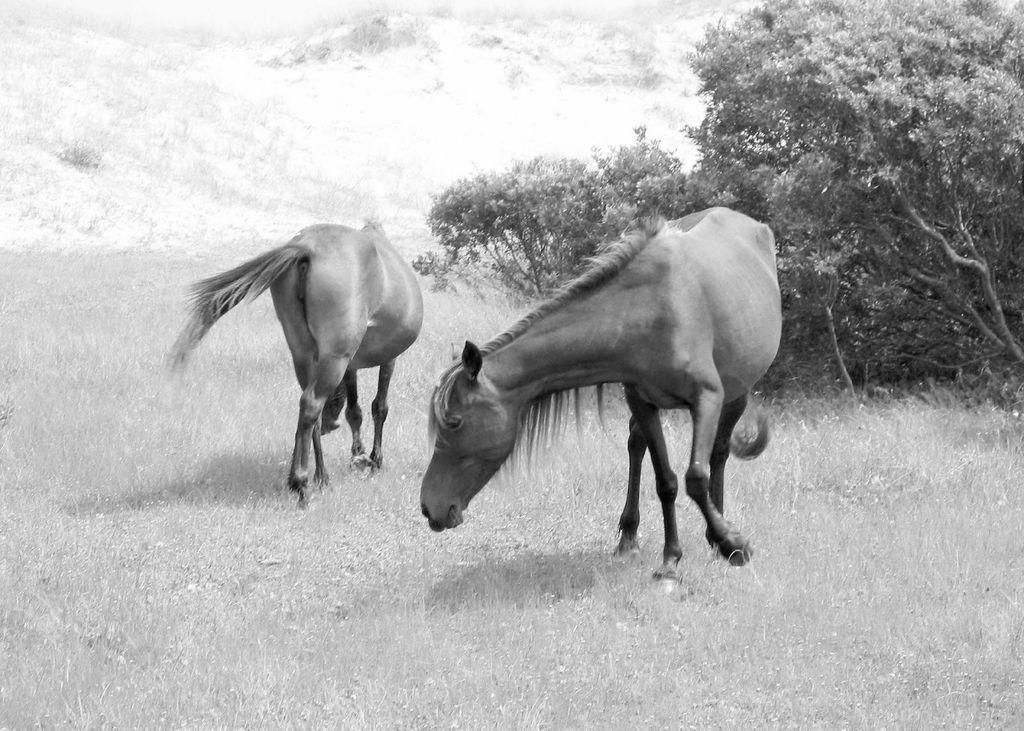Please provide a concise description of this image. It is a black and white picture. In the center of the image we can see two horses. In the background we can see trees, hills, grass etc. 